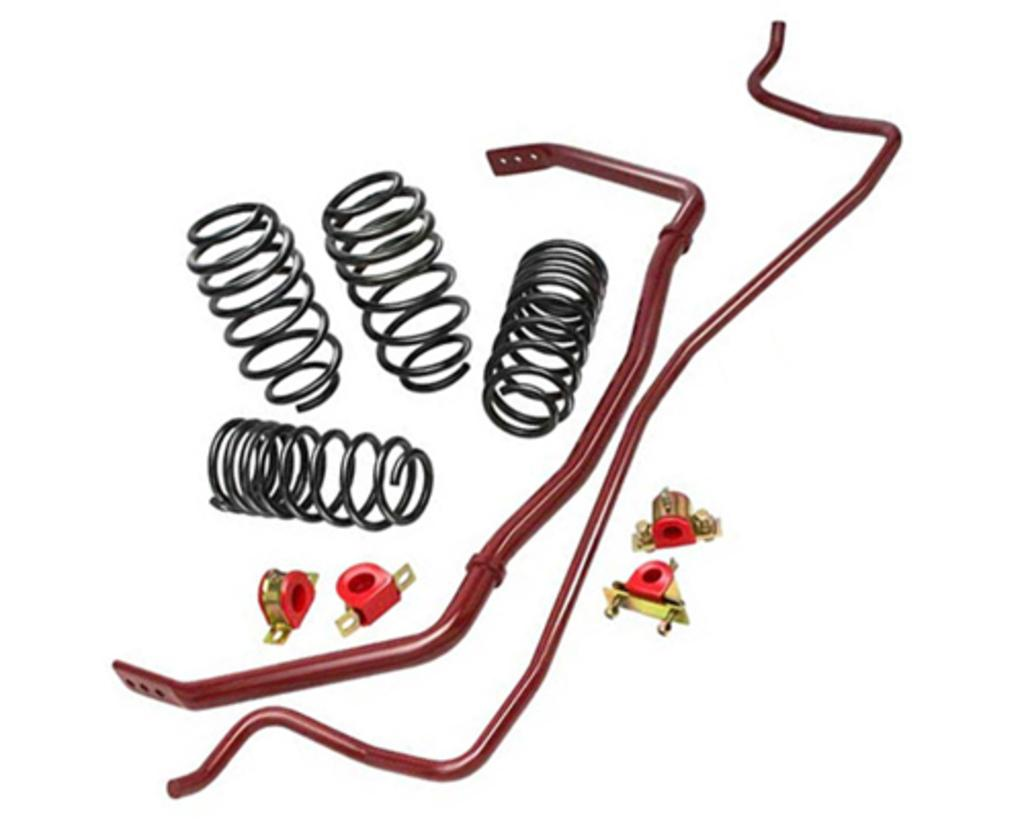What type of objects can be seen in the image? There are springs and metal rods in the image. What is the color of the background in the image? The background of the image is white. What is the reason for the hydrant being present in the image? There is no hydrant present in the image. Is there a fan visible in the image? No, there is no fan visible in the image. 